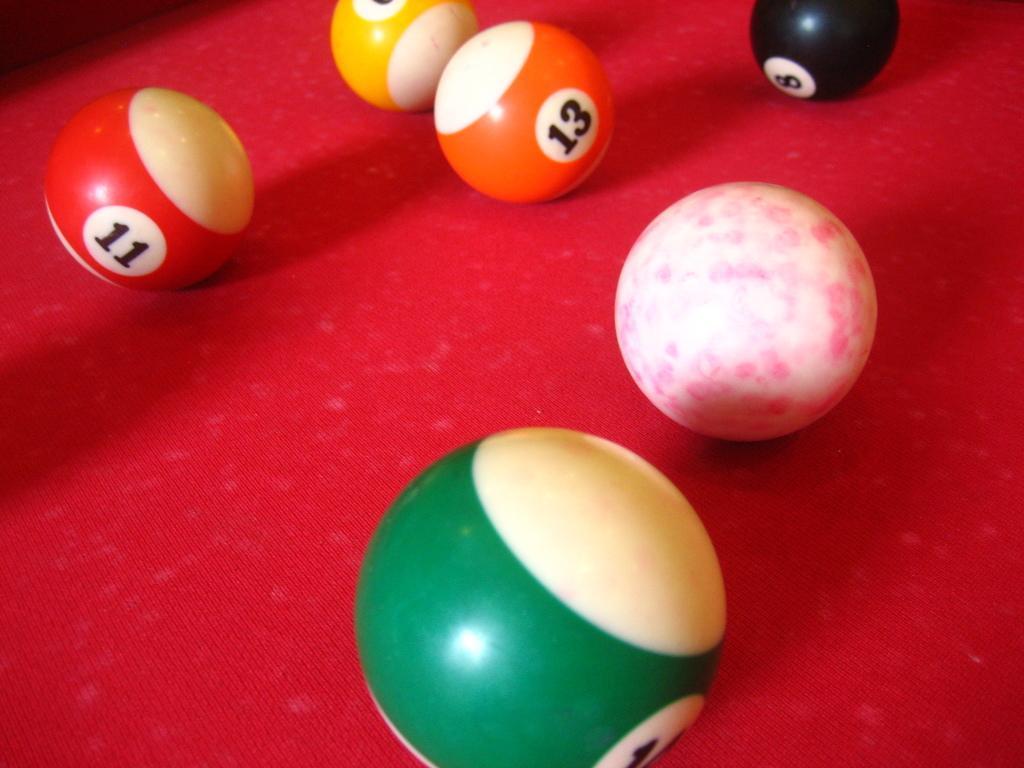Could you give a brief overview of what you see in this image? In this image, I can see the snooker balls on a red color object. 